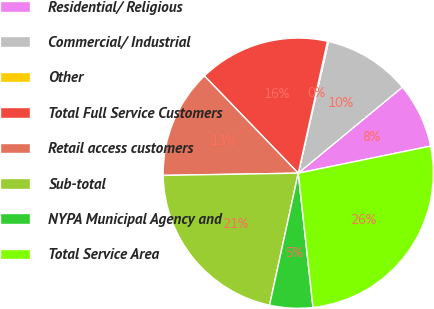Convert chart. <chart><loc_0><loc_0><loc_500><loc_500><pie_chart><fcel>Residential/ Religious<fcel>Commercial/ Industrial<fcel>Other<fcel>Total Full Service Customers<fcel>Retail access customers<fcel>Sub-total<fcel>NYPA Municipal Agency and<fcel>Total Service Area<nl><fcel>7.78%<fcel>10.42%<fcel>0.12%<fcel>15.69%<fcel>13.05%<fcel>21.33%<fcel>5.15%<fcel>26.47%<nl></chart> 